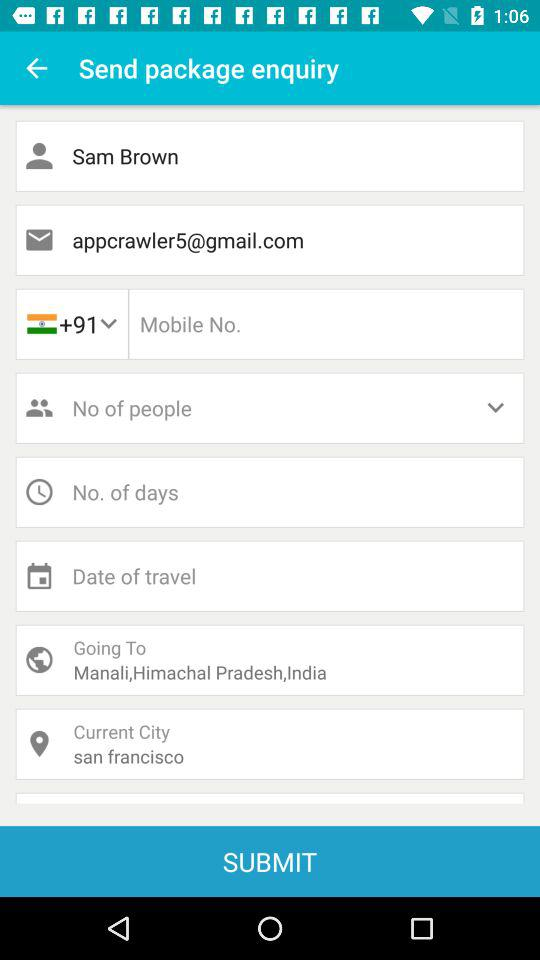Where will Sam Brown go? Sam Brown will go to Manali, Himachal Pradesh, India. 